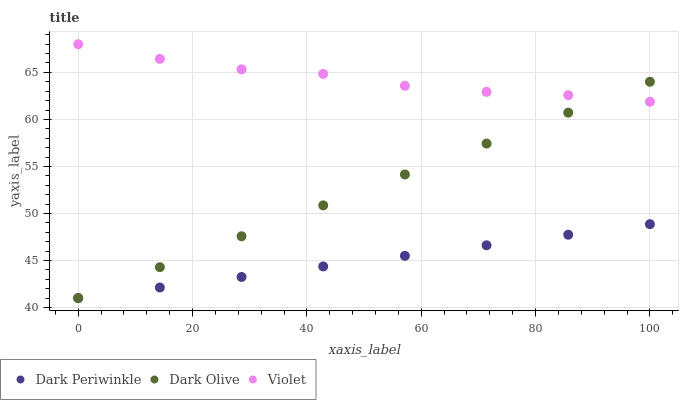Does Dark Periwinkle have the minimum area under the curve?
Answer yes or no. Yes. Does Violet have the maximum area under the curve?
Answer yes or no. Yes. Does Violet have the minimum area under the curve?
Answer yes or no. No. Does Dark Periwinkle have the maximum area under the curve?
Answer yes or no. No. Is Dark Periwinkle the smoothest?
Answer yes or no. Yes. Is Violet the roughest?
Answer yes or no. Yes. Is Violet the smoothest?
Answer yes or no. No. Is Dark Periwinkle the roughest?
Answer yes or no. No. Does Dark Olive have the lowest value?
Answer yes or no. Yes. Does Violet have the lowest value?
Answer yes or no. No. Does Violet have the highest value?
Answer yes or no. Yes. Does Dark Periwinkle have the highest value?
Answer yes or no. No. Is Dark Periwinkle less than Violet?
Answer yes or no. Yes. Is Violet greater than Dark Periwinkle?
Answer yes or no. Yes. Does Dark Olive intersect Dark Periwinkle?
Answer yes or no. Yes. Is Dark Olive less than Dark Periwinkle?
Answer yes or no. No. Is Dark Olive greater than Dark Periwinkle?
Answer yes or no. No. Does Dark Periwinkle intersect Violet?
Answer yes or no. No. 